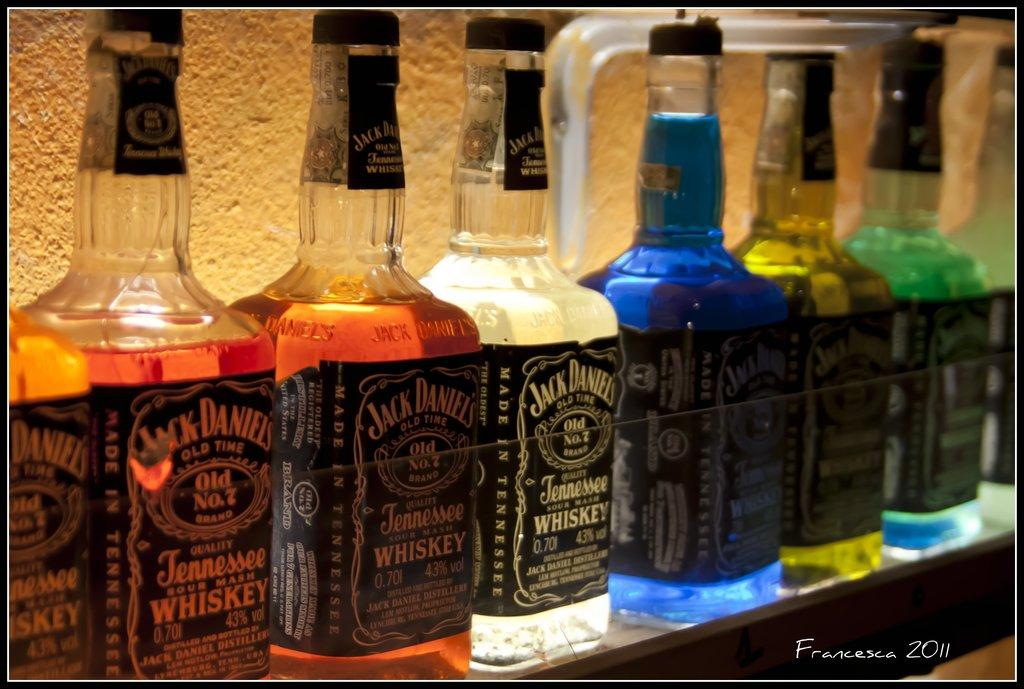What type of beverage containers are present in the image? There are wine bottles in the image. How are the wine bottles arranged on the shelf? The wine bottles are arranged in a row. Where are the wine bottles located in the image? The wine bottles are on a shelf. What type of railway system can be seen in the image? There is no railway system present in the image; it features wine bottles arranged on a shelf. 